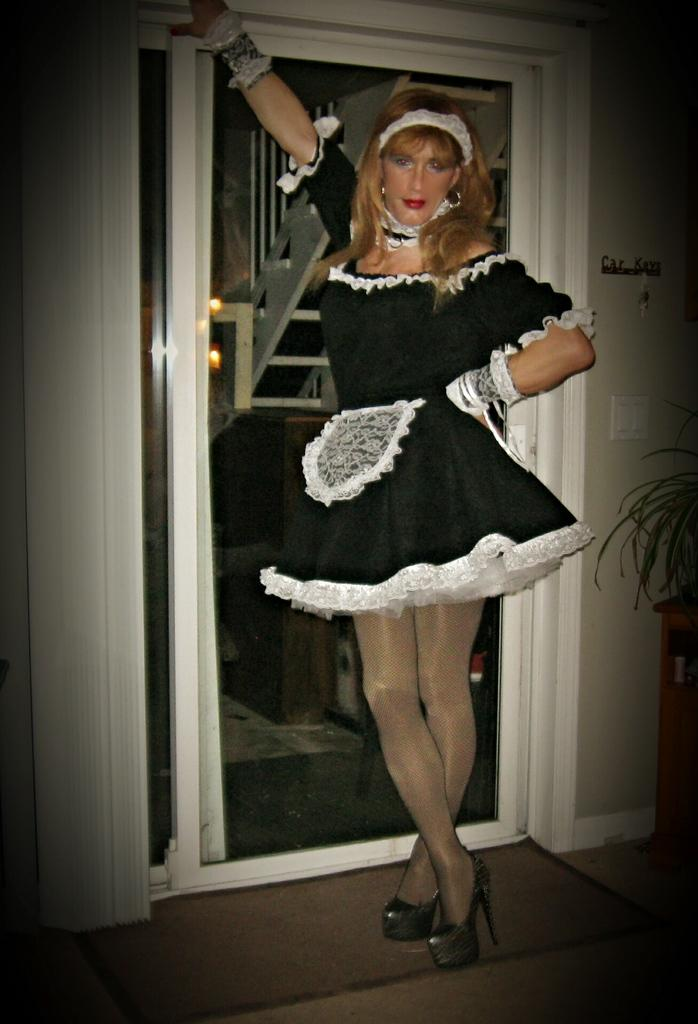What is the girl doing in the image? The girl is standing at a door in the image. What can be seen in the background of the image? There is a plant, a switch board, a wall, and another door in the background of the image. What type of throat surgery is the girl undergoing in the image? There is no indication of any surgery or medical procedure in the image; the girl is simply standing at a door. 